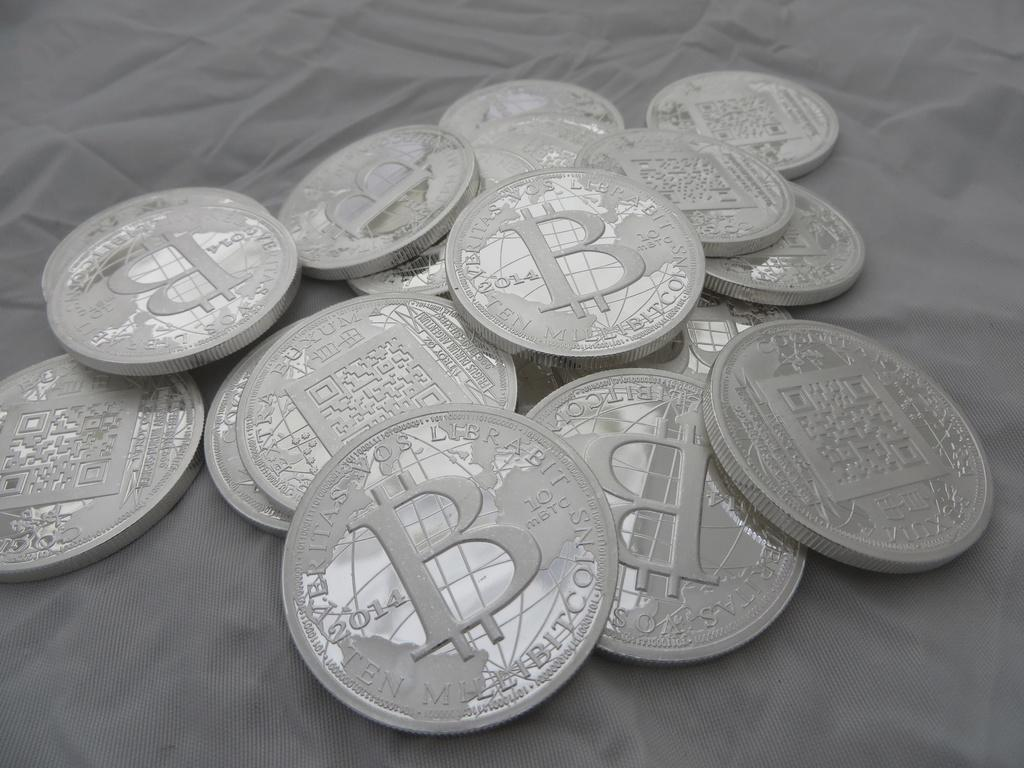<image>
Provide a brief description of the given image. Several bitcoin tokens are shown with a large B in the center and the words "Veritas Vos Librabit" on the top edge. 